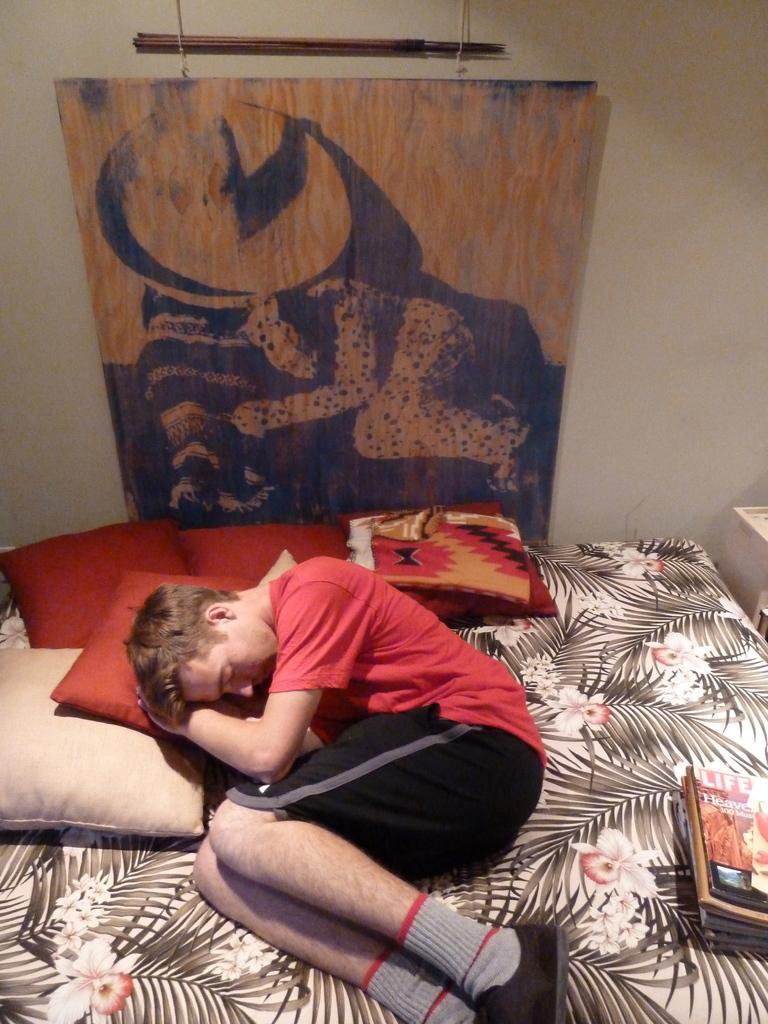How would you summarize this image in a sentence or two? A poster on wall. This person is sleeping on a bed. On this bed there are pillows and books. This person wore red t-shirt. 